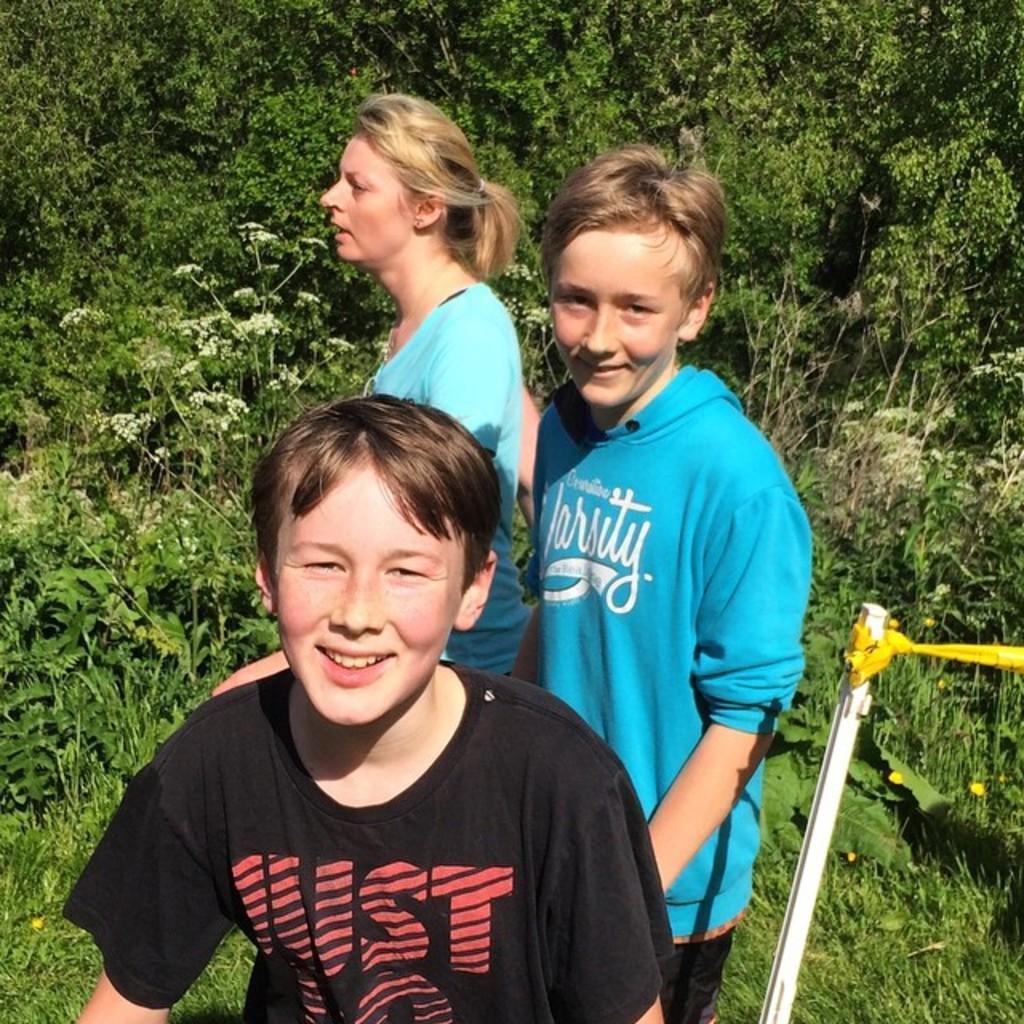Please provide a concise description of this image. In the picture I can see a person wearing black color T-shirt and two persons wearing blue color T-shirts are standing here and smiling. Here we can see a stick with yellow color rope on the right side of the image and we can see grass and plants in the background of the image. 